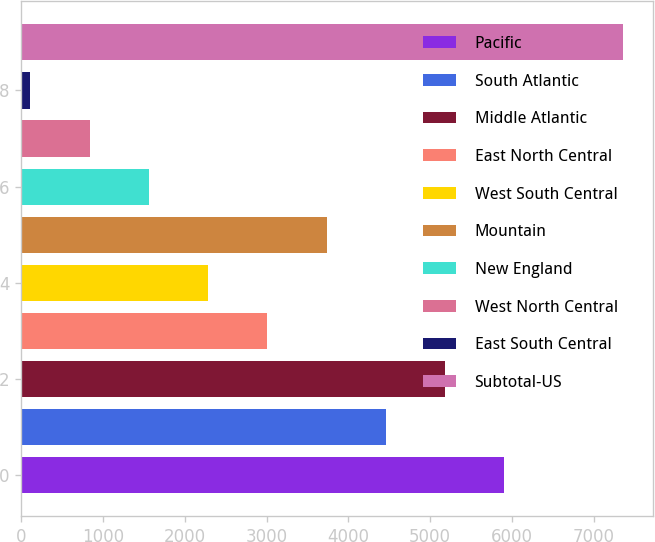Convert chart. <chart><loc_0><loc_0><loc_500><loc_500><bar_chart><fcel>Pacific<fcel>South Atlantic<fcel>Middle Atlantic<fcel>East North Central<fcel>West South Central<fcel>Mountain<fcel>New England<fcel>West North Central<fcel>East South Central<fcel>Subtotal-US<nl><fcel>5905<fcel>4457<fcel>5181<fcel>3009<fcel>2285<fcel>3733<fcel>1561<fcel>837<fcel>113<fcel>7353<nl></chart> 